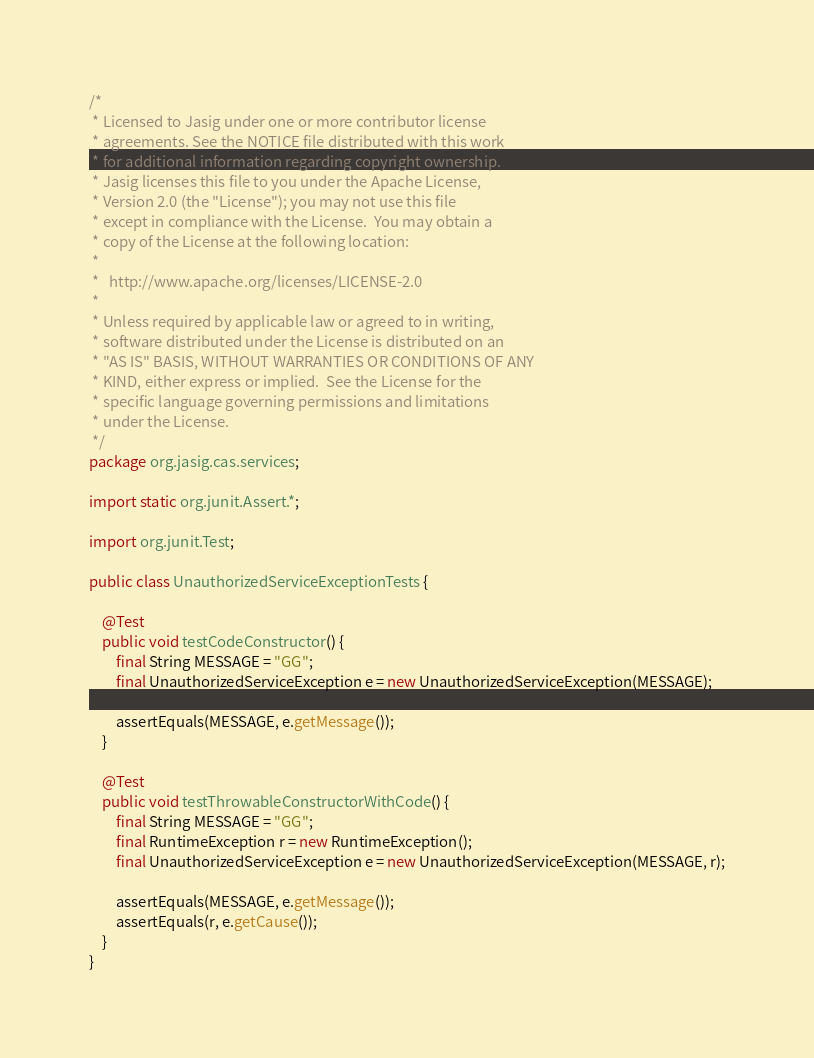<code> <loc_0><loc_0><loc_500><loc_500><_Java_>/*
 * Licensed to Jasig under one or more contributor license
 * agreements. See the NOTICE file distributed with this work
 * for additional information regarding copyright ownership.
 * Jasig licenses this file to you under the Apache License,
 * Version 2.0 (the "License"); you may not use this file
 * except in compliance with the License.  You may obtain a
 * copy of the License at the following location:
 *
 *   http://www.apache.org/licenses/LICENSE-2.0
 *
 * Unless required by applicable law or agreed to in writing,
 * software distributed under the License is distributed on an
 * "AS IS" BASIS, WITHOUT WARRANTIES OR CONDITIONS OF ANY
 * KIND, either express or implied.  See the License for the
 * specific language governing permissions and limitations
 * under the License.
 */
package org.jasig.cas.services;

import static org.junit.Assert.*;

import org.junit.Test;

public class UnauthorizedServiceExceptionTests {

    @Test
    public void testCodeConstructor() {
        final String MESSAGE = "GG";
        final UnauthorizedServiceException e = new UnauthorizedServiceException(MESSAGE);

        assertEquals(MESSAGE, e.getMessage());
    }

    @Test
    public void testThrowableConstructorWithCode() {
        final String MESSAGE = "GG";
        final RuntimeException r = new RuntimeException();
        final UnauthorizedServiceException e = new UnauthorizedServiceException(MESSAGE, r);

        assertEquals(MESSAGE, e.getMessage());
        assertEquals(r, e.getCause());
    }
}
</code> 